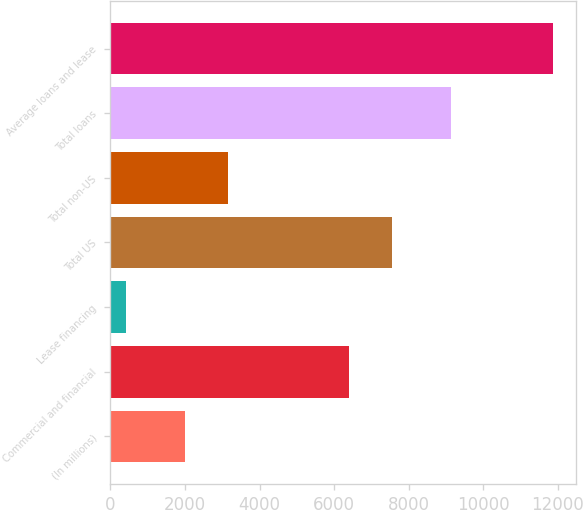Convert chart to OTSL. <chart><loc_0><loc_0><loc_500><loc_500><bar_chart><fcel>(In millions)<fcel>Commercial and financial<fcel>Lease financing<fcel>Total US<fcel>Total non-US<fcel>Total loans<fcel>Average loans and lease<nl><fcel>2008<fcel>6397<fcel>407<fcel>7544.7<fcel>3155.7<fcel>9131<fcel>11884<nl></chart> 